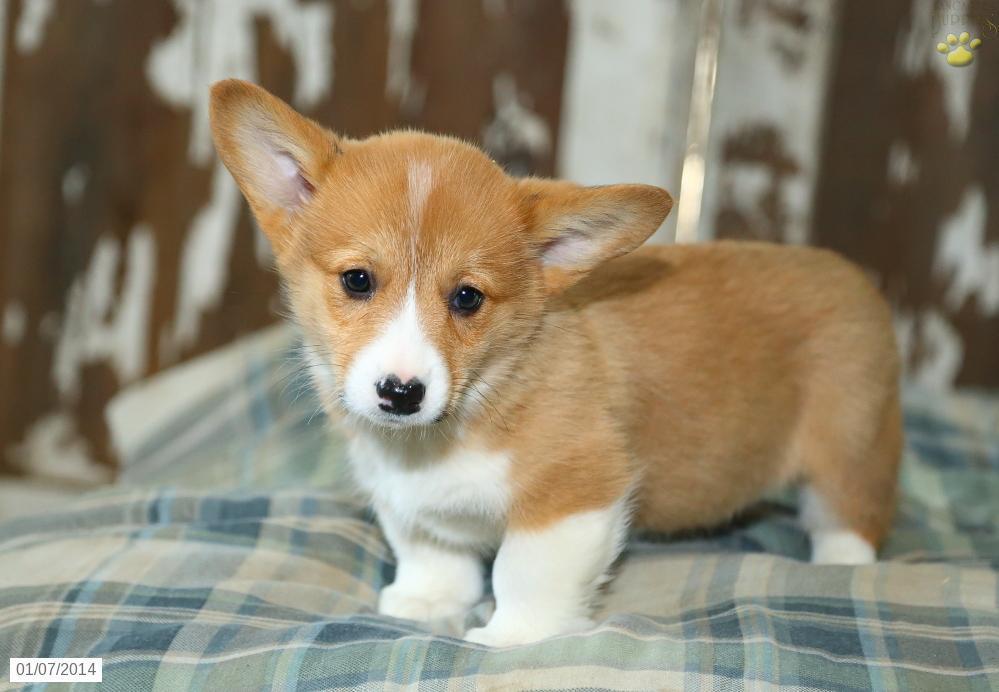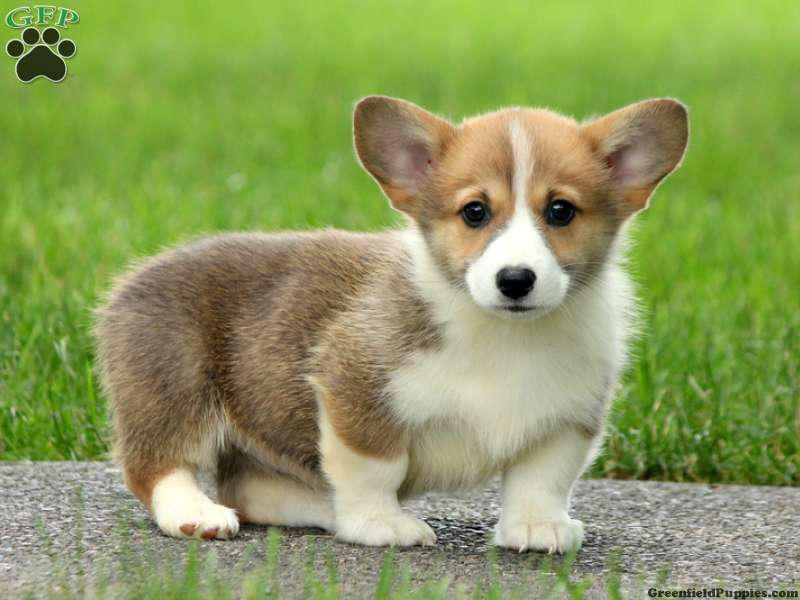The first image is the image on the left, the second image is the image on the right. Examine the images to the left and right. Is the description "There are at least three Corgis in the image." accurate? Answer yes or no. No. 